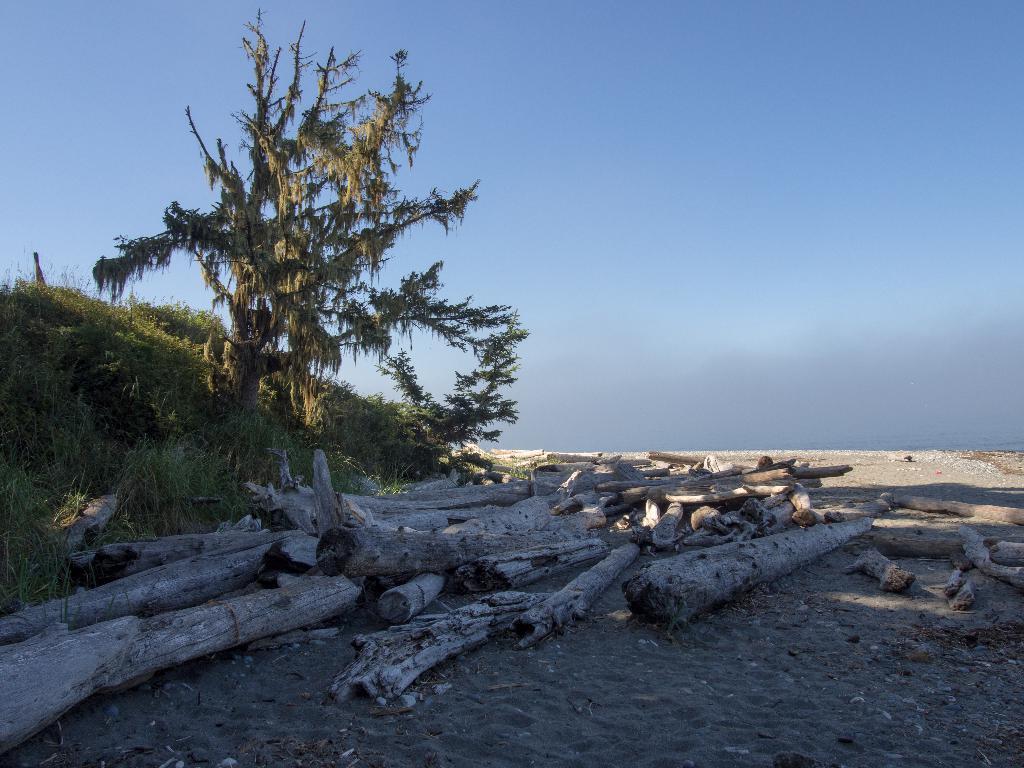Describe this image in one or two sentences. In this image we can able to see a tree and some bushes, there are some wooden trunks on the surface, and we can see sky. 